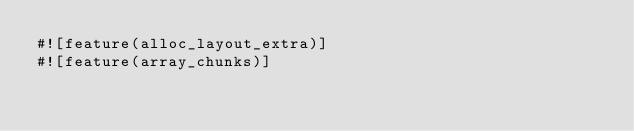<code> <loc_0><loc_0><loc_500><loc_500><_Rust_>#![feature(alloc_layout_extra)]
#![feature(array_chunks)]</code> 